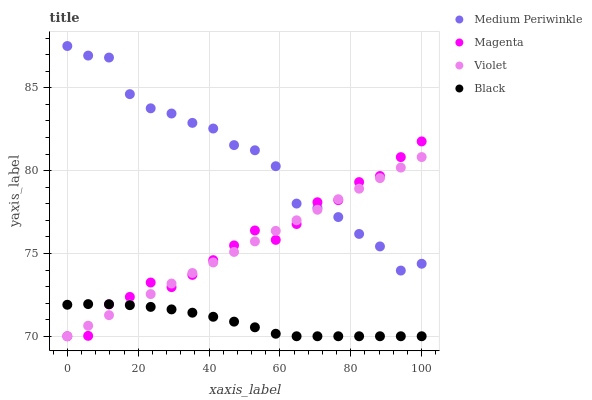Does Black have the minimum area under the curve?
Answer yes or no. Yes. Does Medium Periwinkle have the maximum area under the curve?
Answer yes or no. Yes. Does Magenta have the minimum area under the curve?
Answer yes or no. No. Does Magenta have the maximum area under the curve?
Answer yes or no. No. Is Violet the smoothest?
Answer yes or no. Yes. Is Medium Periwinkle the roughest?
Answer yes or no. Yes. Is Magenta the smoothest?
Answer yes or no. No. Is Magenta the roughest?
Answer yes or no. No. Does Black have the lowest value?
Answer yes or no. Yes. Does Medium Periwinkle have the lowest value?
Answer yes or no. No. Does Medium Periwinkle have the highest value?
Answer yes or no. Yes. Does Magenta have the highest value?
Answer yes or no. No. Is Black less than Medium Periwinkle?
Answer yes or no. Yes. Is Medium Periwinkle greater than Black?
Answer yes or no. Yes. Does Violet intersect Magenta?
Answer yes or no. Yes. Is Violet less than Magenta?
Answer yes or no. No. Is Violet greater than Magenta?
Answer yes or no. No. Does Black intersect Medium Periwinkle?
Answer yes or no. No. 